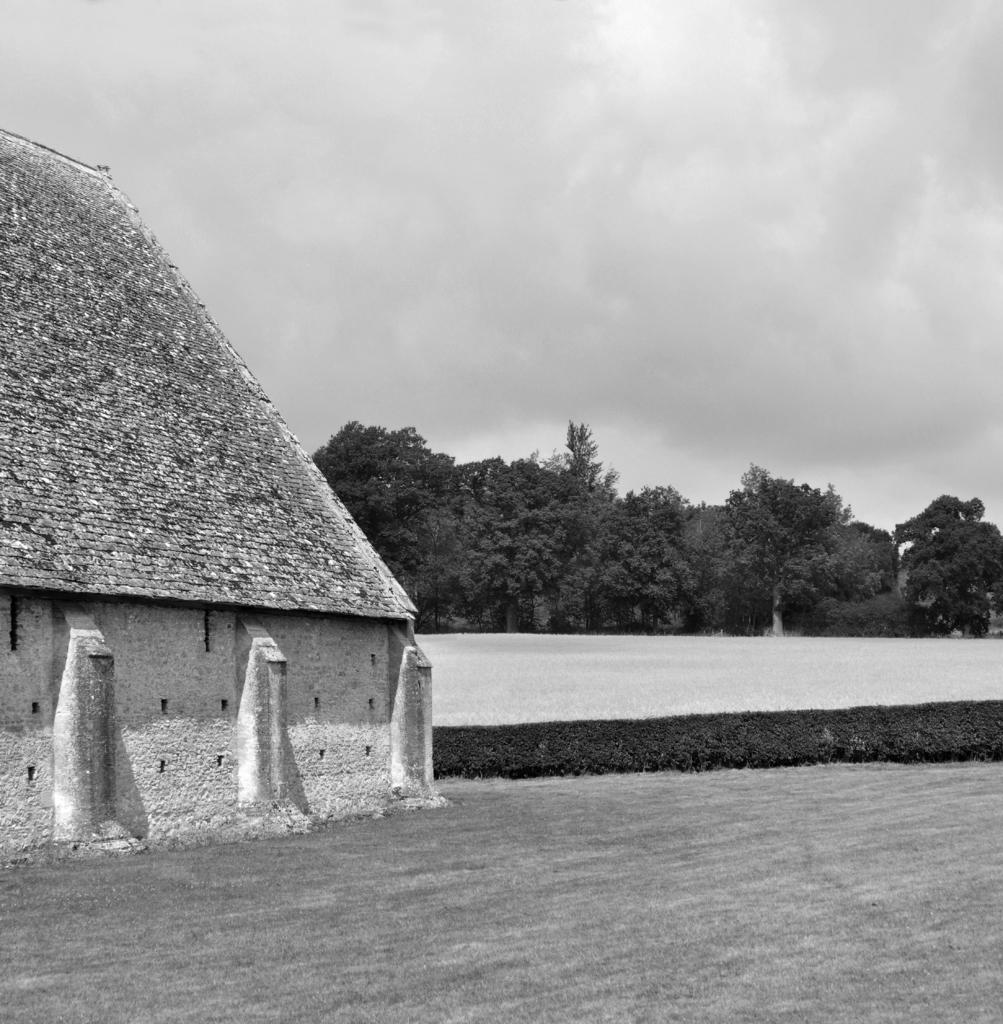What is the color scheme of the image? The image is black and white. What is located in the foreground of the image? There is a building, plants, and trees in the foreground of the image. What can be seen in the background of the image? The sky is visible in the image. How many pages are visible in the image? There are no pages present in the image. What type of air is depicted in the image? There is no specific type of air depicted in the image; it is simply the sky visible in the background. 